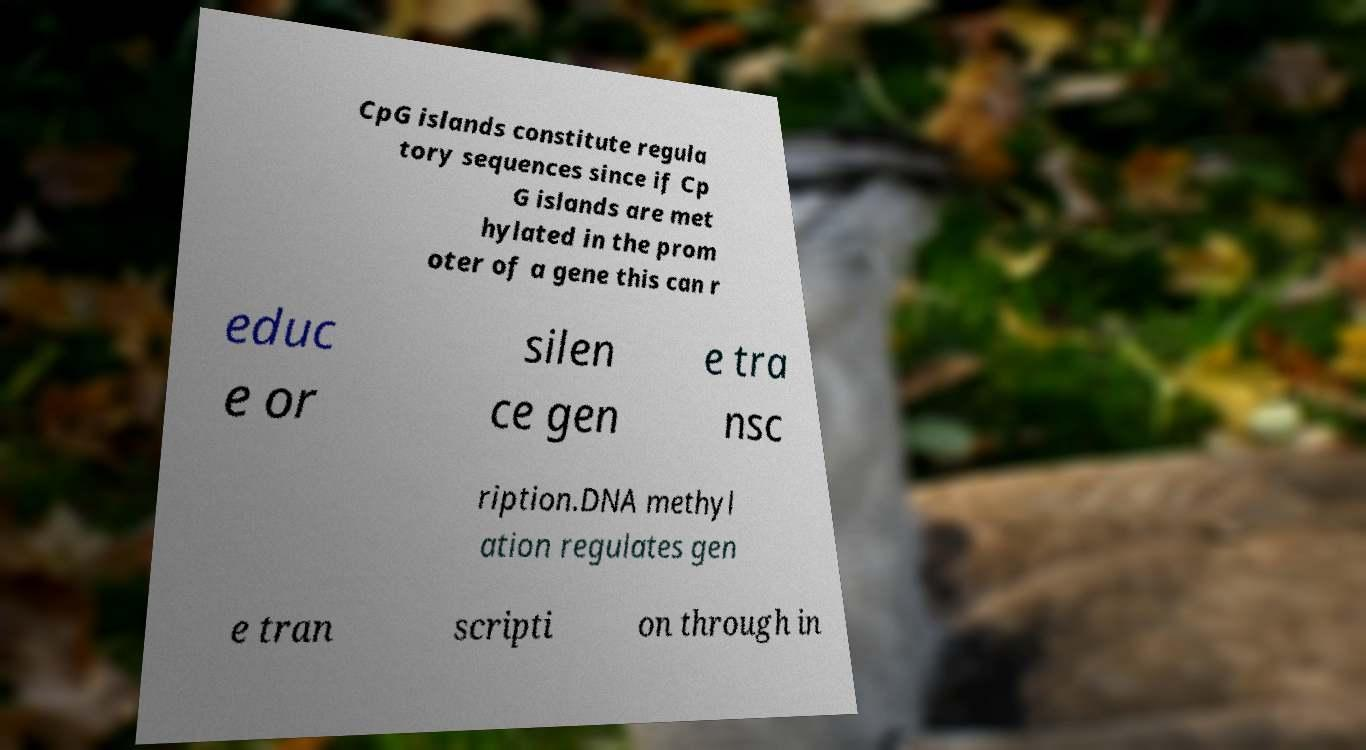What messages or text are displayed in this image? I need them in a readable, typed format. CpG islands constitute regula tory sequences since if Cp G islands are met hylated in the prom oter of a gene this can r educ e or silen ce gen e tra nsc ription.DNA methyl ation regulates gen e tran scripti on through in 